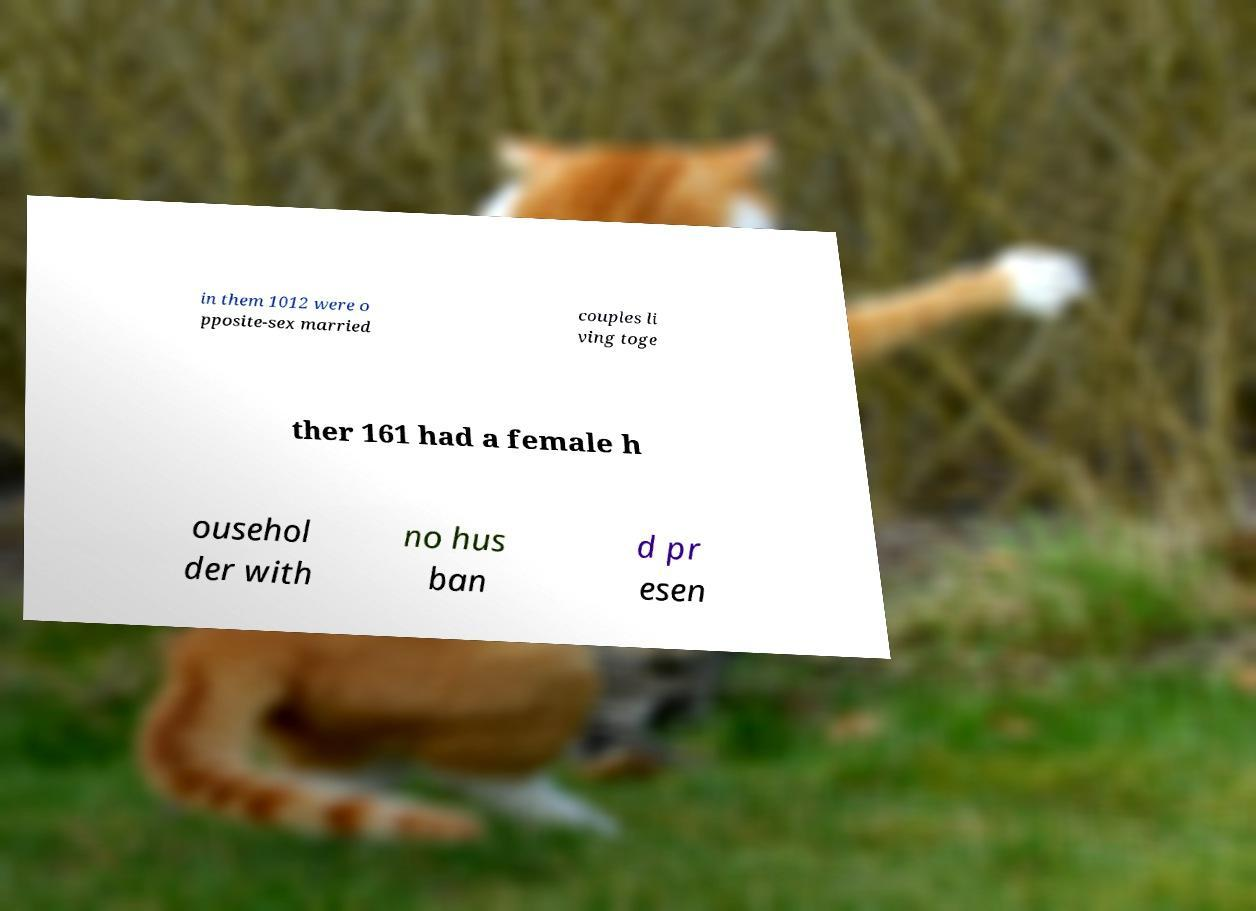Could you assist in decoding the text presented in this image and type it out clearly? in them 1012 were o pposite-sex married couples li ving toge ther 161 had a female h ousehol der with no hus ban d pr esen 